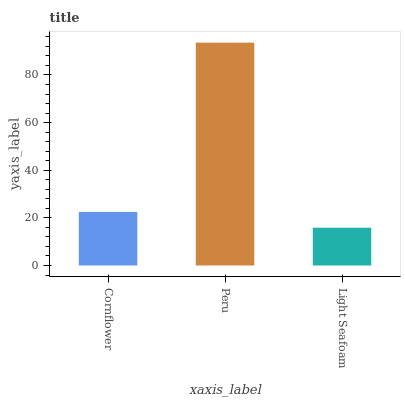Is Light Seafoam the minimum?
Answer yes or no. Yes. Is Peru the maximum?
Answer yes or no. Yes. Is Peru the minimum?
Answer yes or no. No. Is Light Seafoam the maximum?
Answer yes or no. No. Is Peru greater than Light Seafoam?
Answer yes or no. Yes. Is Light Seafoam less than Peru?
Answer yes or no. Yes. Is Light Seafoam greater than Peru?
Answer yes or no. No. Is Peru less than Light Seafoam?
Answer yes or no. No. Is Cornflower the high median?
Answer yes or no. Yes. Is Cornflower the low median?
Answer yes or no. Yes. Is Peru the high median?
Answer yes or no. No. Is Light Seafoam the low median?
Answer yes or no. No. 